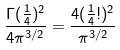Convert formula to latex. <formula><loc_0><loc_0><loc_500><loc_500>\frac { \Gamma ( \frac { 1 } { 4 } ) ^ { 2 } } { 4 \pi ^ { 3 / 2 } } = \frac { 4 ( \frac { 1 } { 4 } ! ) ^ { 2 } } { \pi ^ { 3 / 2 } }</formula> 